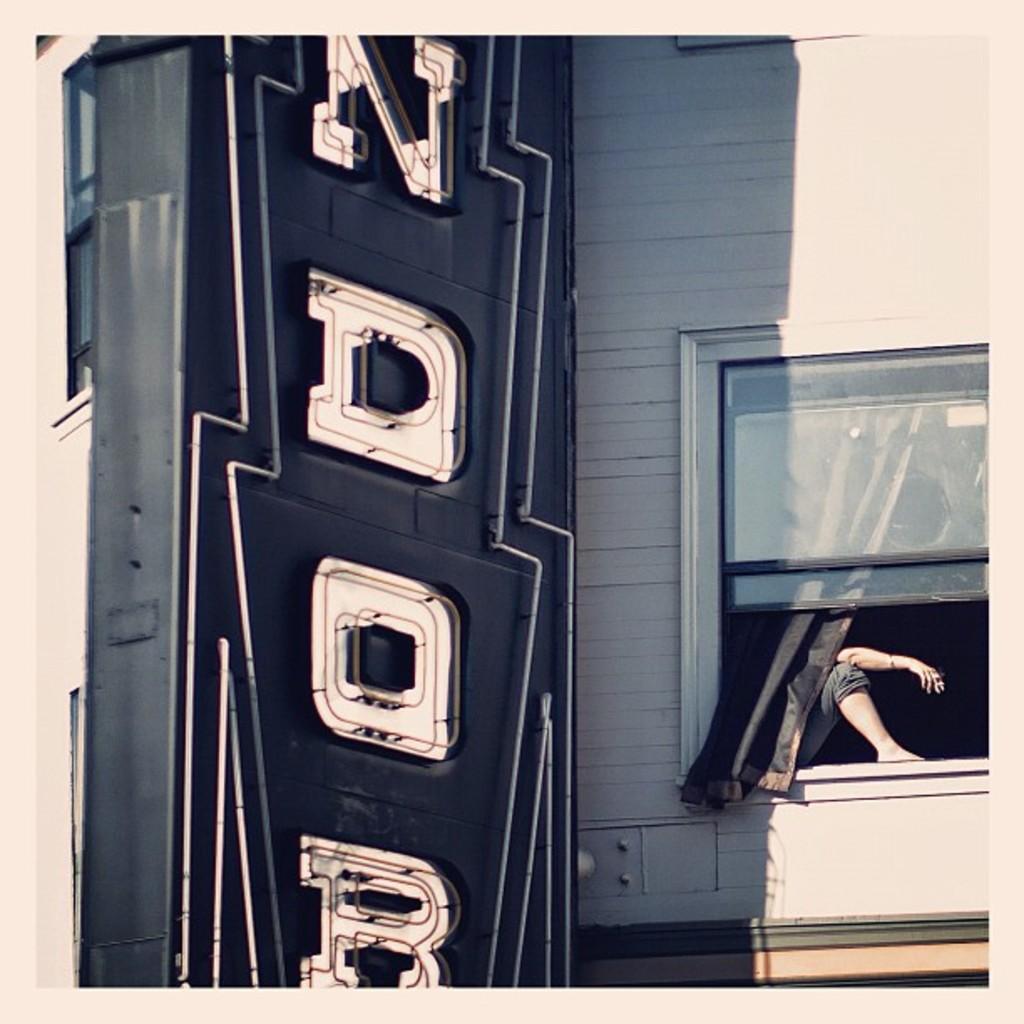Could you give a brief overview of what you see in this image? In this image, we can see a person sitting in the window and we can see a hoarding. 